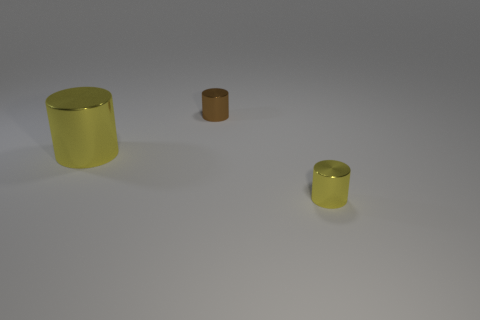Add 3 tiny brown metal objects. How many objects exist? 6 Subtract all big yellow shiny cylinders. Subtract all tiny rubber things. How many objects are left? 2 Add 1 brown objects. How many brown objects are left? 2 Add 1 brown cylinders. How many brown cylinders exist? 2 Subtract 0 green spheres. How many objects are left? 3 